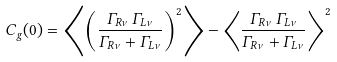<formula> <loc_0><loc_0><loc_500><loc_500>C _ { g } ( 0 ) = \left \langle \left ( \frac { \Gamma _ { R \nu } \, \Gamma _ { L \nu } } { \Gamma _ { R \nu } + \Gamma _ { L \nu } } \right ) ^ { 2 } \right \rangle - \left \langle \frac { \Gamma _ { R \nu } \, \Gamma _ { L \nu } } { \Gamma _ { R \nu } + \Gamma _ { L \nu } } \right \rangle ^ { 2 }</formula> 